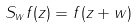Convert formula to latex. <formula><loc_0><loc_0><loc_500><loc_500>S _ { w } f ( z ) = f ( z + w )</formula> 